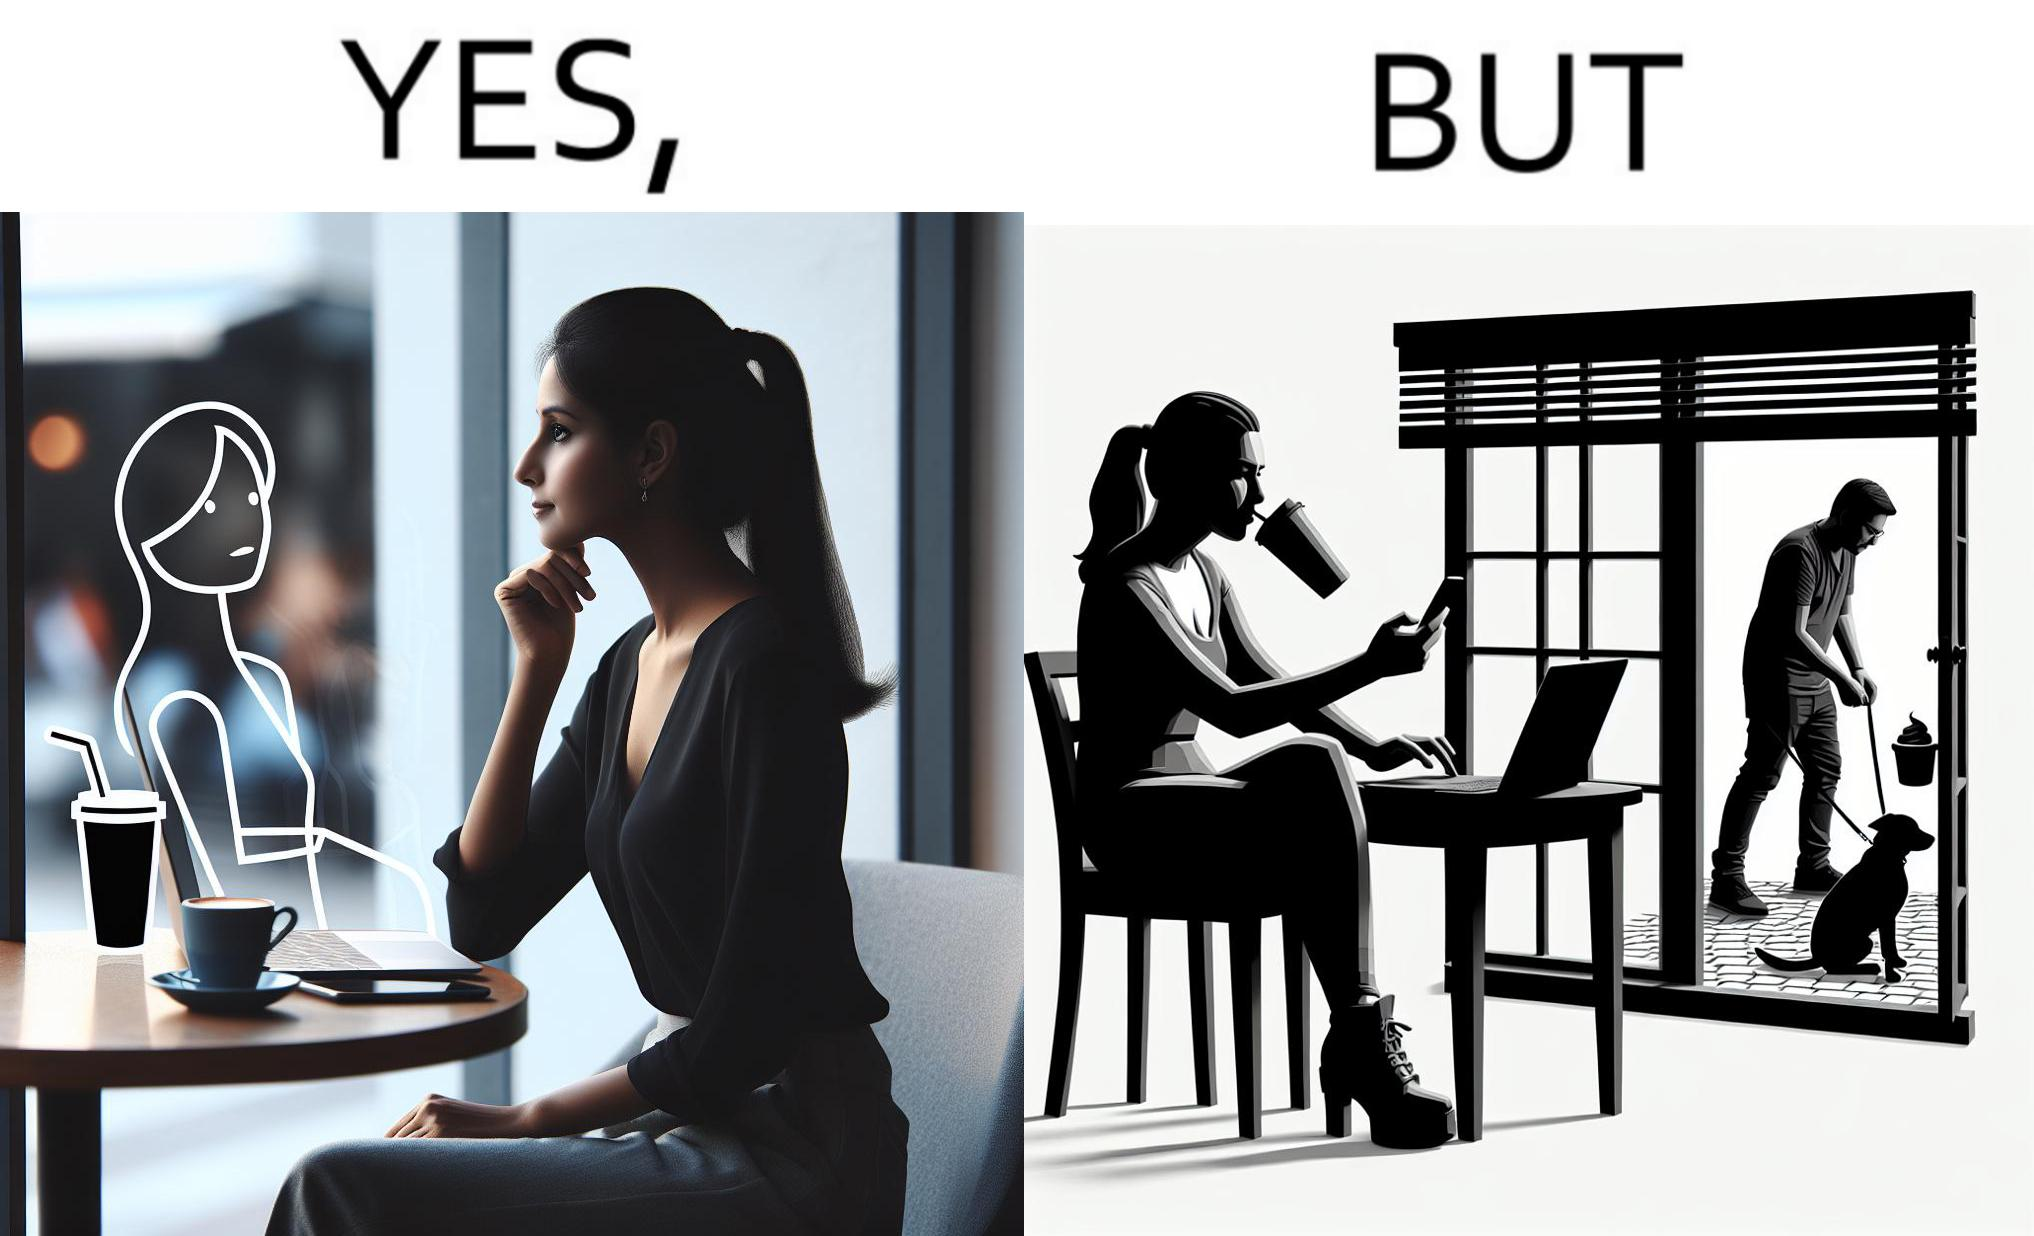Why is this image considered satirical? The image is ironic, because in the first image the woman is seen as enjoying the view but in the second image the same woman is seen as looking at a pooping dog 